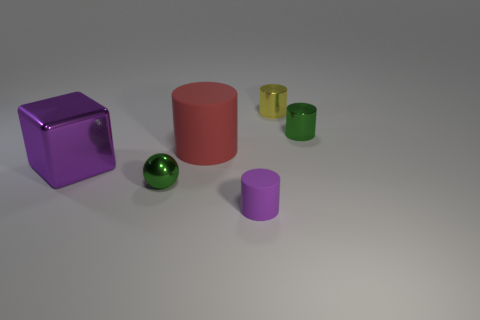Is the number of cubes behind the large metal thing the same as the number of red cylinders?
Ensure brevity in your answer.  No. Is the size of the green metallic cylinder the same as the purple metallic block?
Your answer should be compact. No. There is another thing that is the same size as the red thing; what color is it?
Your answer should be very brief. Purple. There is a green cylinder; does it have the same size as the green thing that is on the left side of the small purple matte cylinder?
Provide a succinct answer. Yes. How many big blocks are the same color as the small matte thing?
Your response must be concise. 1. What number of things are big yellow metallic objects or tiny things that are on the right side of the metal sphere?
Provide a succinct answer. 3. There is a rubber cylinder that is in front of the large red rubber object; is it the same size as the rubber thing that is behind the tiny purple rubber thing?
Provide a succinct answer. No. Is there a red thing made of the same material as the small purple object?
Provide a succinct answer. Yes. What is the shape of the tiny purple object?
Provide a short and direct response. Cylinder. There is a tiny object right of the small cylinder behind the tiny green cylinder; what shape is it?
Your response must be concise. Cylinder. 